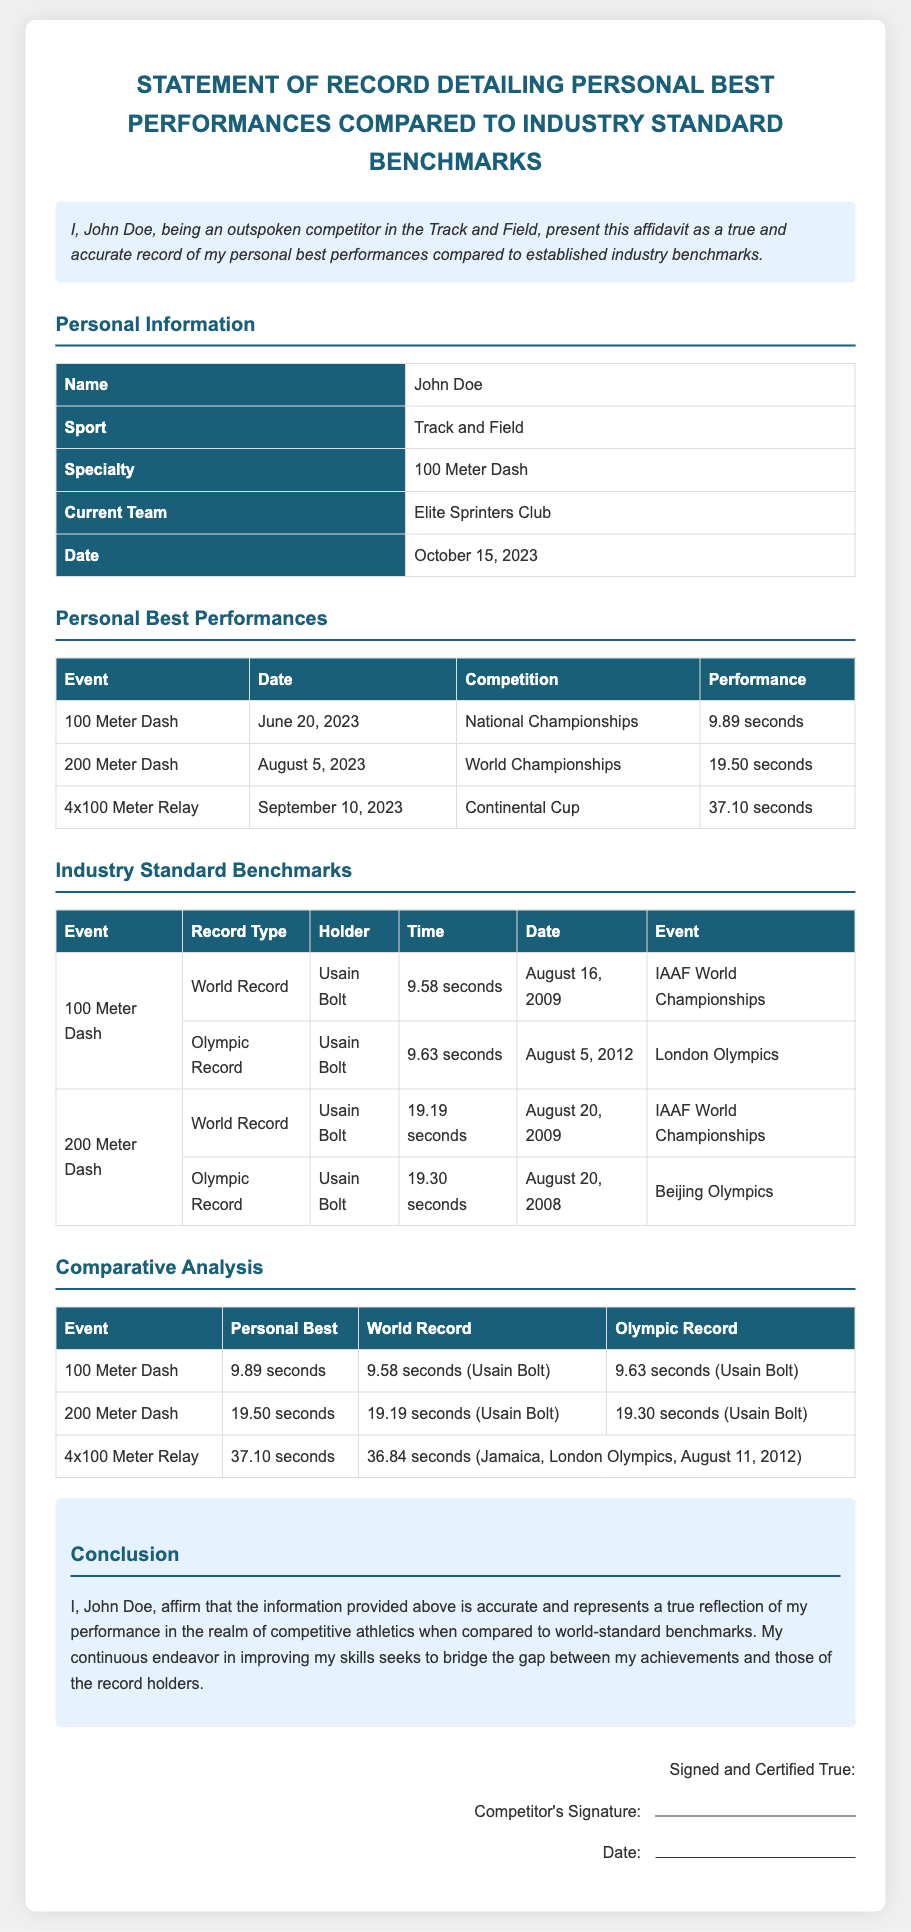What is the name of the competitor? The name provided in the document is John Doe, who is the competitor mentioned.
Answer: John Doe What event did John Doe achieve his personal best on June 20, 2023? The document specifies that the event on this date is the 100 Meter Dash.
Answer: 100 Meter Dash What is John Doe's personal best time in the 200 Meter Dash? According to the document, his personal best time in this event is 19.50 seconds.
Answer: 19.50 seconds Who holds the world record for the 100 Meter Dash? The document states that Usain Bolt holds the world record for this event.
Answer: Usain Bolt What is the Olympic Record for the 200 Meter Dash? The Olympic Record listed in the document for this event is 19.30 seconds.
Answer: 19.30 seconds What is the performance time for the 4x100 Meter Relay completed by John Doe? The document indicates that his performance time for this relay is 37.10 seconds.
Answer: 37.10 seconds How does John Doe's personal best in the 100 Meter Dash compare to the world record? The document shows that John Doe's personal best of 9.89 seconds is slower than the world record of 9.58 seconds.
Answer: Slower What type of document is presented? The document is a signed affidavit detailing personal best performances compared to industry benchmarks.
Answer: Affidavit What is the conclusion stated by John Doe regarding the information in the document? The conclusion states that the information is accurate and reflects his performance compared to world-standard benchmarks.
Answer: Accurate and reflects performance 